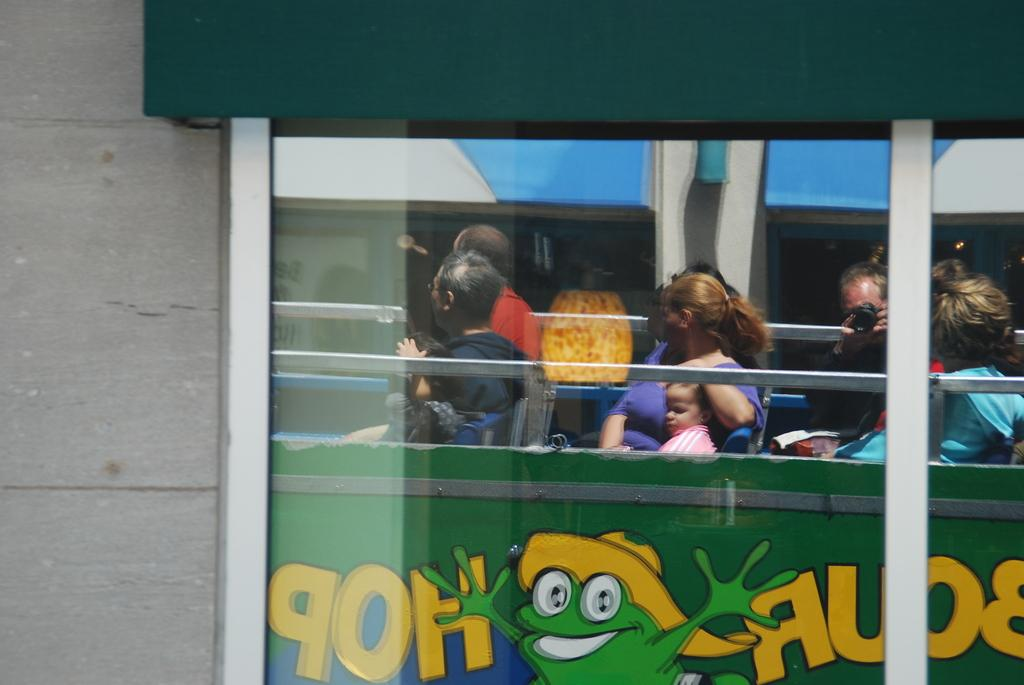What type of structure is visible in the image? There is a building in the image. What feature can be seen on the building? The building has windows. What type of wall is present in the image? There is a brick wall in the image. What can be seen reflected in the windows of the building? The windows reflect a bus. What is happening inside the bus? The bus has people sitting in seats. What type of scene is being depicted in the image? The image does not depict a scene; it shows a building, a brick wall, and a bus reflected in the windows. Are there any slaves or cooks present in the image? There is no mention of slaves or cooks in the image; it primarily features a building, a brick wall, and a bus reflected in the windows. 